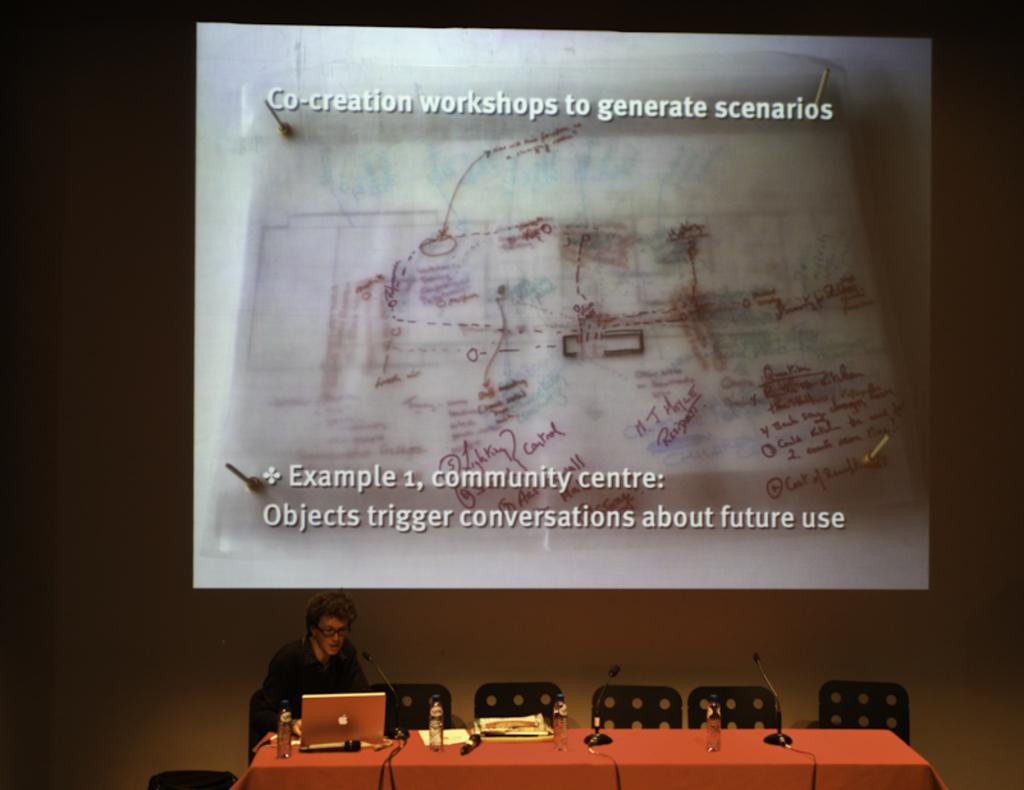Could you give a brief overview of what you see in this image? In this picture there is a person sitting in chair and there is a table in front of him which has a laptop,few water bottles and mics on it and there is a projected image in the background. 